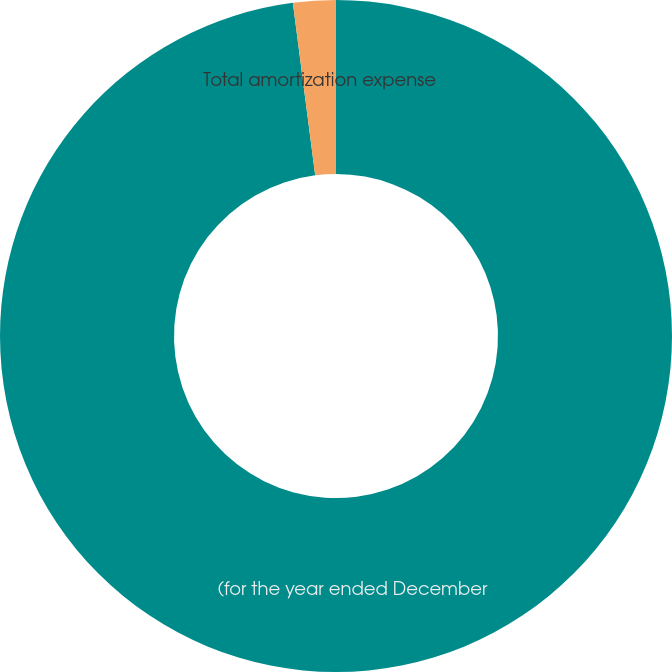Convert chart to OTSL. <chart><loc_0><loc_0><loc_500><loc_500><pie_chart><fcel>(for the year ended December<fcel>Total amortization expense<nl><fcel>97.95%<fcel>2.05%<nl></chart> 